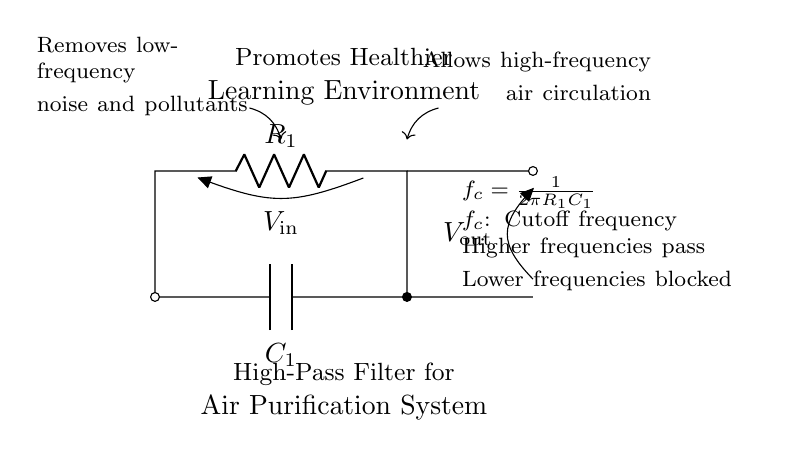What type of filter is shown in the circuit? The circuit diagram indicates a high-pass filter, as indicated in the title and by the properties outlined in the node descriptions.
Answer: high-pass filter What is the cutoff frequency formula presented in the diagram? The cutoff frequency is defined as \( f_c = \frac{1}{2\pi R_1C_1} \), which is clearly stated in the explanation section of the diagram.
Answer: f_c = 1/(2πR_1C_1) What components are included in this filter circuit? The circuit contains a resistor labeled \( R_1 \) and a capacitor denoted as \( C_1 \), as identified in the component labels on the diagram.
Answer: Resistor and capacitor What effect does the high-pass filter have on low-frequency signals? The explanation notes that the high-pass filter removes low-frequency noise and pollutants, which clarifies its function regarding unwanted lower frequencies.
Answer: Removes low-frequency noise What happens to higher frequencies in this circuit? According to the characteristics mentioned, higher frequencies are allowed to pass, making the air purification system more effective in air circulation and quality.
Answer: Allows high frequencies to pass Why is the high-pass filter crucial for a classroom environment? The filter is essential as it promotes a healthier learning environment by eliminating low-frequency contaminants and supporting better air quality with high-frequency circulation.
Answer: Promotes a healthier learning environment 